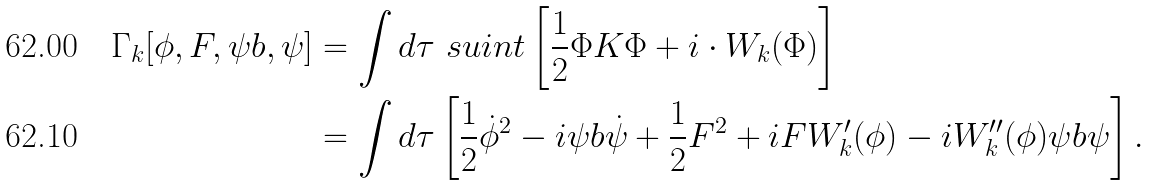<formula> <loc_0><loc_0><loc_500><loc_500>\Gamma _ { k } [ \phi , F , { \psi b } , \psi ] & = \int d \tau \ s u i n t \left [ \frac { 1 } { 2 } \Phi K \Phi + i \cdot W _ { k } ( \Phi ) \right ] \\ & = \int d \tau \left [ \frac { 1 } { 2 } \dot { \phi } ^ { 2 } - i \psi b \dot { \psi } + \frac { 1 } { 2 } F ^ { 2 } + i F W ^ { \prime } _ { k } ( \phi ) - i W ^ { \prime \prime } _ { k } ( \phi ) \psi b \psi \right ] .</formula> 